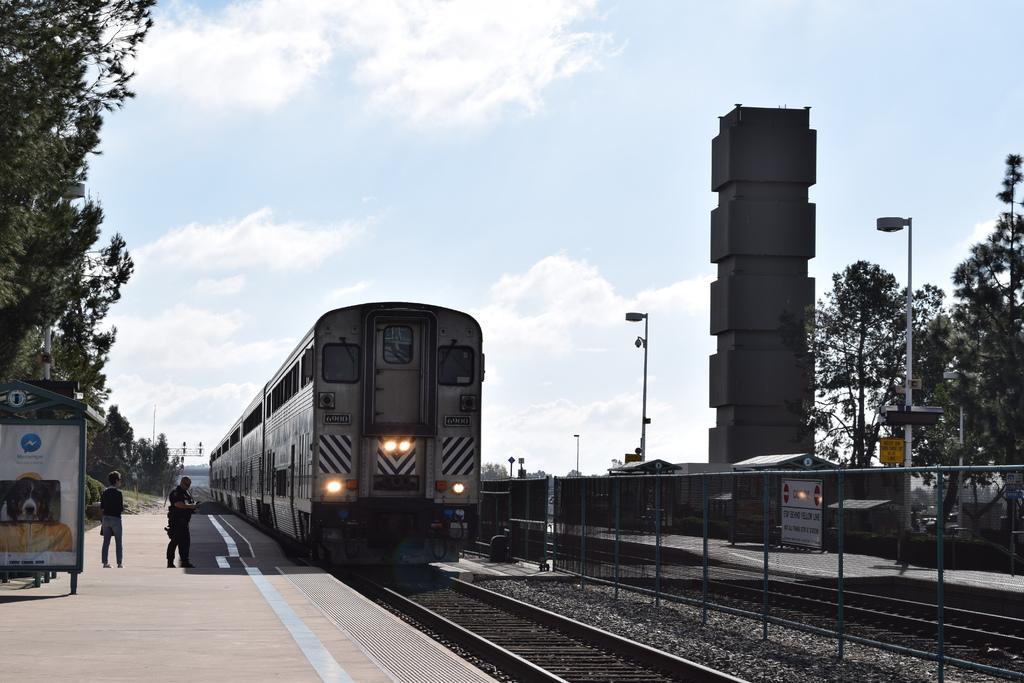Can you describe this image briefly? There are two persons and trees are present on the left side of this image and there is a train and railway tracks in the middle of this image. We can see trees on the right side of this image. There is a cloudy sky at the top of this image. 